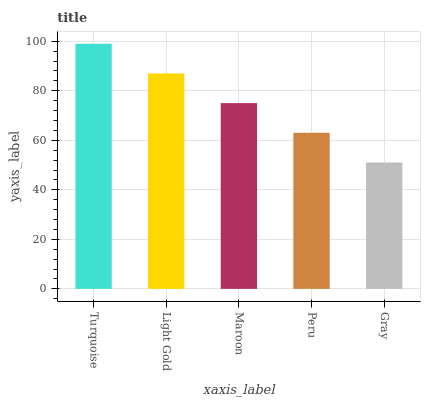Is Gray the minimum?
Answer yes or no. Yes. Is Turquoise the maximum?
Answer yes or no. Yes. Is Light Gold the minimum?
Answer yes or no. No. Is Light Gold the maximum?
Answer yes or no. No. Is Turquoise greater than Light Gold?
Answer yes or no. Yes. Is Light Gold less than Turquoise?
Answer yes or no. Yes. Is Light Gold greater than Turquoise?
Answer yes or no. No. Is Turquoise less than Light Gold?
Answer yes or no. No. Is Maroon the high median?
Answer yes or no. Yes. Is Maroon the low median?
Answer yes or no. Yes. Is Peru the high median?
Answer yes or no. No. Is Light Gold the low median?
Answer yes or no. No. 